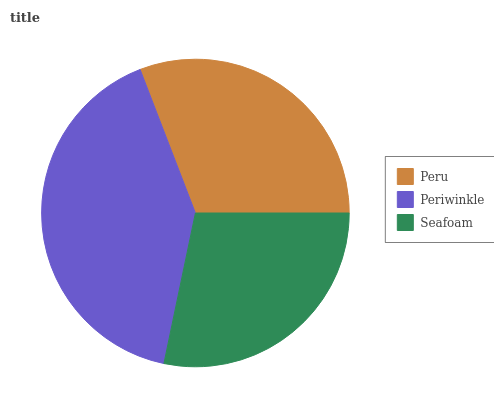Is Seafoam the minimum?
Answer yes or no. Yes. Is Periwinkle the maximum?
Answer yes or no. Yes. Is Periwinkle the minimum?
Answer yes or no. No. Is Seafoam the maximum?
Answer yes or no. No. Is Periwinkle greater than Seafoam?
Answer yes or no. Yes. Is Seafoam less than Periwinkle?
Answer yes or no. Yes. Is Seafoam greater than Periwinkle?
Answer yes or no. No. Is Periwinkle less than Seafoam?
Answer yes or no. No. Is Peru the high median?
Answer yes or no. Yes. Is Peru the low median?
Answer yes or no. Yes. Is Periwinkle the high median?
Answer yes or no. No. Is Periwinkle the low median?
Answer yes or no. No. 